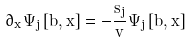Convert formula to latex. <formula><loc_0><loc_0><loc_500><loc_500>\partial _ { x } \Psi _ { j } \left [ b , x \right ] = - \frac { s _ { j } } { v } \Psi _ { j } \left [ b , x \right ]</formula> 